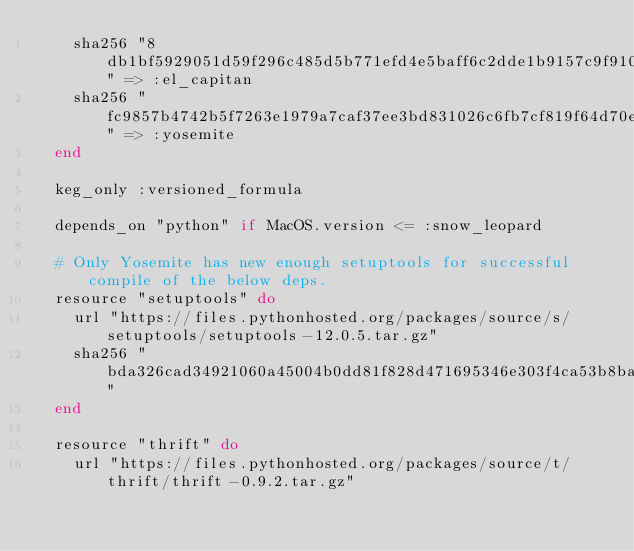Convert code to text. <code><loc_0><loc_0><loc_500><loc_500><_Ruby_>    sha256 "8db1bf5929051d59f296c485d5b771efd4e5baff6c2dde1b9157c9f910f45f8f" => :el_capitan
    sha256 "fc9857b4742b5f7263e1979a7caf37ee3bd831026c6fb7cf819f64d70edaed7b" => :yosemite
  end

  keg_only :versioned_formula

  depends_on "python" if MacOS.version <= :snow_leopard

  # Only Yosemite has new enough setuptools for successful compile of the below deps.
  resource "setuptools" do
    url "https://files.pythonhosted.org/packages/source/s/setuptools/setuptools-12.0.5.tar.gz"
    sha256 "bda326cad34921060a45004b0dd81f828d471695346e303f4ca53b8ba6f4547f"
  end

  resource "thrift" do
    url "https://files.pythonhosted.org/packages/source/t/thrift/thrift-0.9.2.tar.gz"</code> 